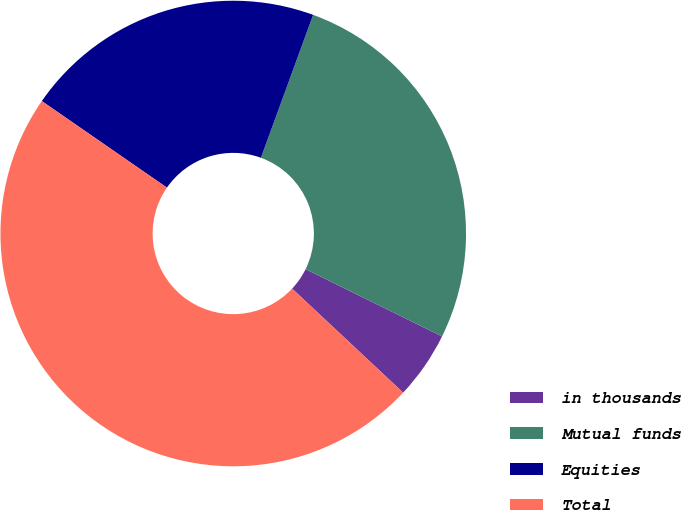Convert chart to OTSL. <chart><loc_0><loc_0><loc_500><loc_500><pie_chart><fcel>in thousands<fcel>Mutual funds<fcel>Equities<fcel>Total<nl><fcel>4.69%<fcel>26.71%<fcel>20.94%<fcel>47.65%<nl></chart> 